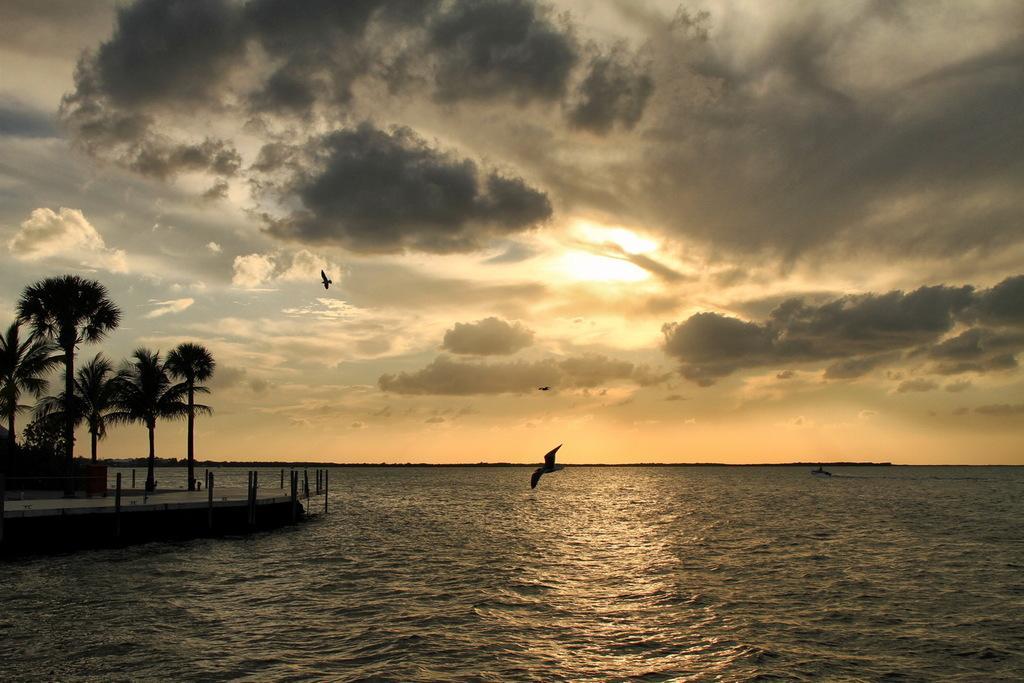Can you describe this image briefly? In this picture I can see at the bottom there is water, in the middle few birds are flying. On the left side there are trees and it looks like a wooden bridge. At the top there is the sky. 